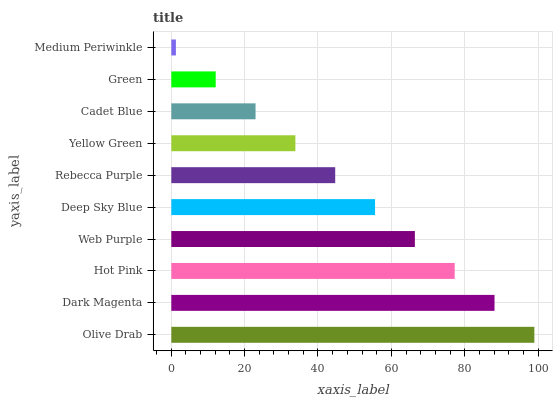Is Medium Periwinkle the minimum?
Answer yes or no. Yes. Is Olive Drab the maximum?
Answer yes or no. Yes. Is Dark Magenta the minimum?
Answer yes or no. No. Is Dark Magenta the maximum?
Answer yes or no. No. Is Olive Drab greater than Dark Magenta?
Answer yes or no. Yes. Is Dark Magenta less than Olive Drab?
Answer yes or no. Yes. Is Dark Magenta greater than Olive Drab?
Answer yes or no. No. Is Olive Drab less than Dark Magenta?
Answer yes or no. No. Is Deep Sky Blue the high median?
Answer yes or no. Yes. Is Rebecca Purple the low median?
Answer yes or no. Yes. Is Dark Magenta the high median?
Answer yes or no. No. Is Olive Drab the low median?
Answer yes or no. No. 